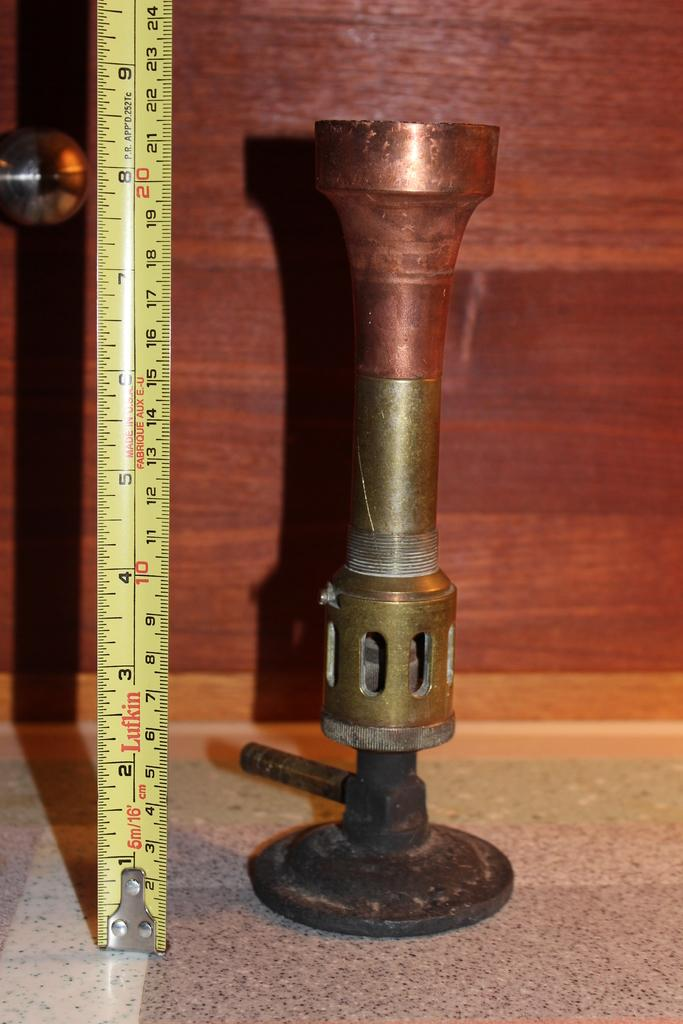What is the object on the floor in the image? There is a measuring tape on the floor in the image. What else can be seen on the floor in the image? There is no other object mentioned on the floor besides the measuring tape. What type of object can be seen in the background of the image? There is a wooden object in the background of the image. What type of comb is used to style the yam in the image? There is no yam or comb present in the image. How is the eggnog being served in the image? There is no eggnog present in the image. 